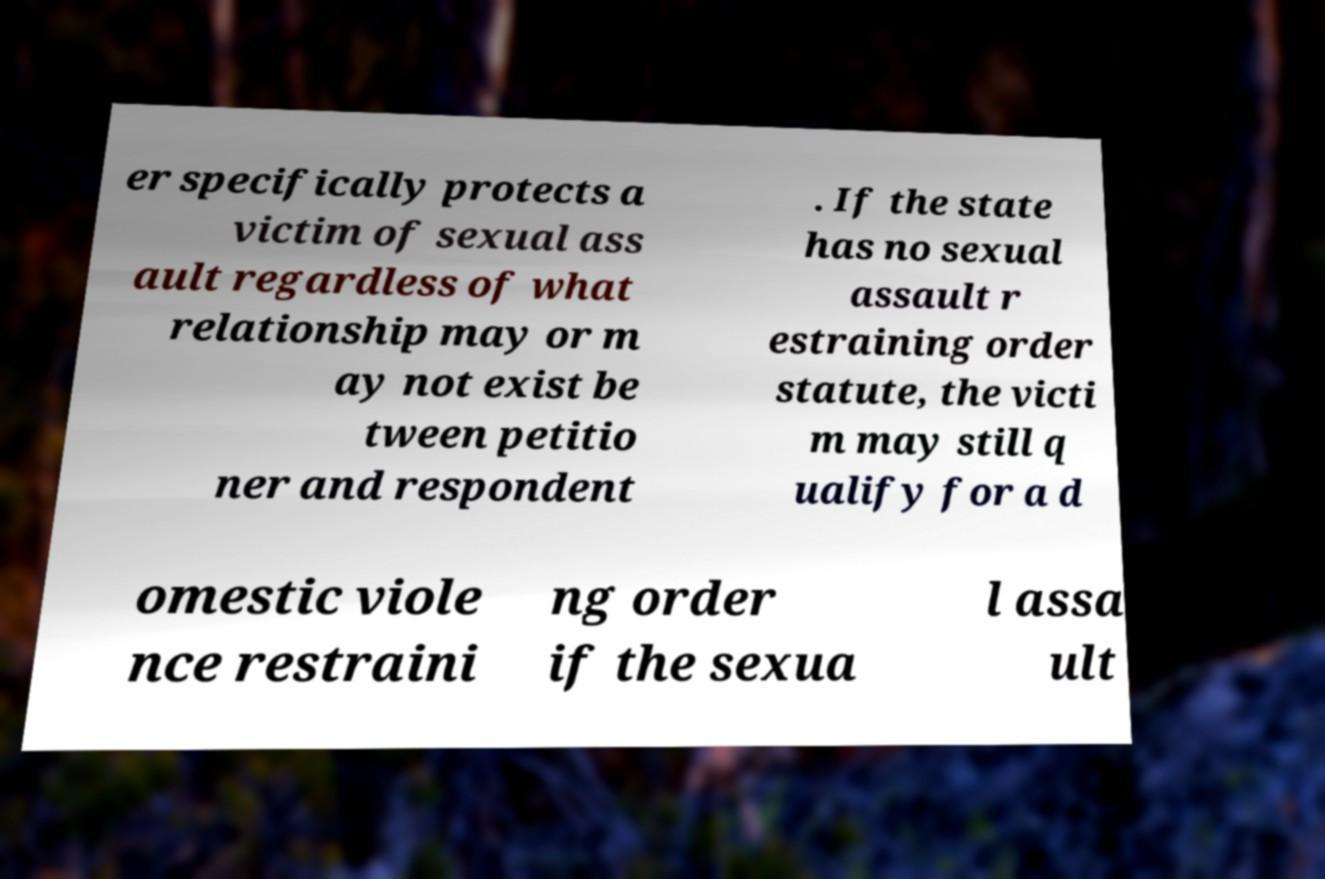Can you accurately transcribe the text from the provided image for me? er specifically protects a victim of sexual ass ault regardless of what relationship may or m ay not exist be tween petitio ner and respondent . If the state has no sexual assault r estraining order statute, the victi m may still q ualify for a d omestic viole nce restraini ng order if the sexua l assa ult 